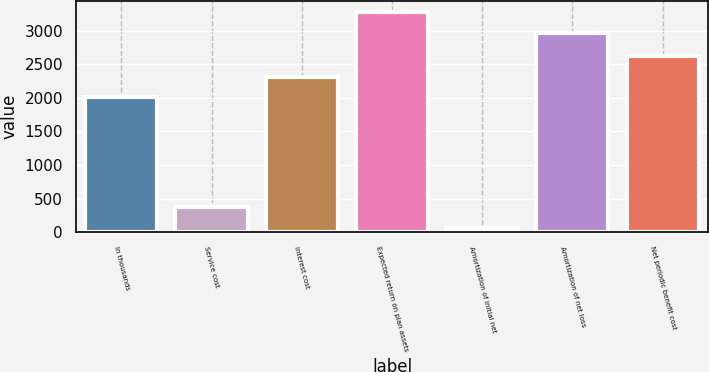Convert chart to OTSL. <chart><loc_0><loc_0><loc_500><loc_500><bar_chart><fcel>In thousands<fcel>Service cost<fcel>Interest cost<fcel>Expected return on plan assets<fcel>Amortization of initial net<fcel>Amortization of net loss<fcel>Net periodic benefit cost<nl><fcel>2012<fcel>379<fcel>2315.3<fcel>3271.3<fcel>62<fcel>2968<fcel>2618.6<nl></chart> 